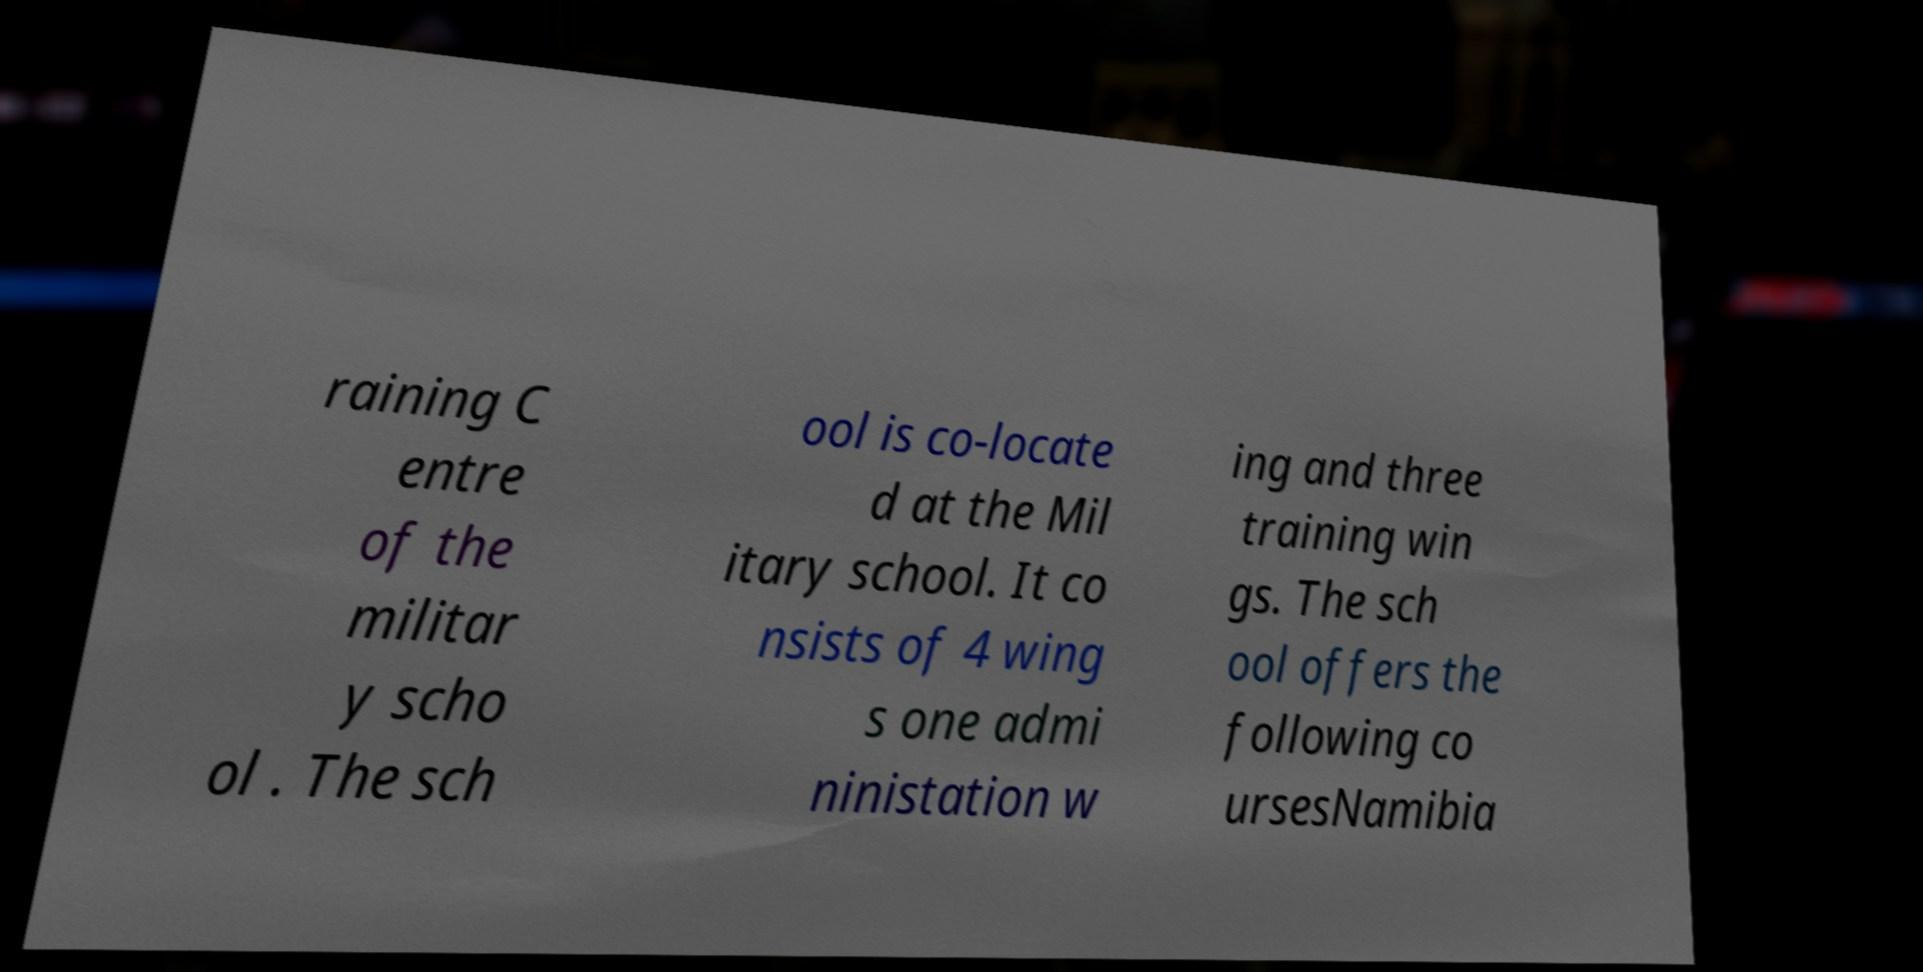I need the written content from this picture converted into text. Can you do that? raining C entre of the militar y scho ol . The sch ool is co-locate d at the Mil itary school. It co nsists of 4 wing s one admi ninistation w ing and three training win gs. The sch ool offers the following co ursesNamibia 